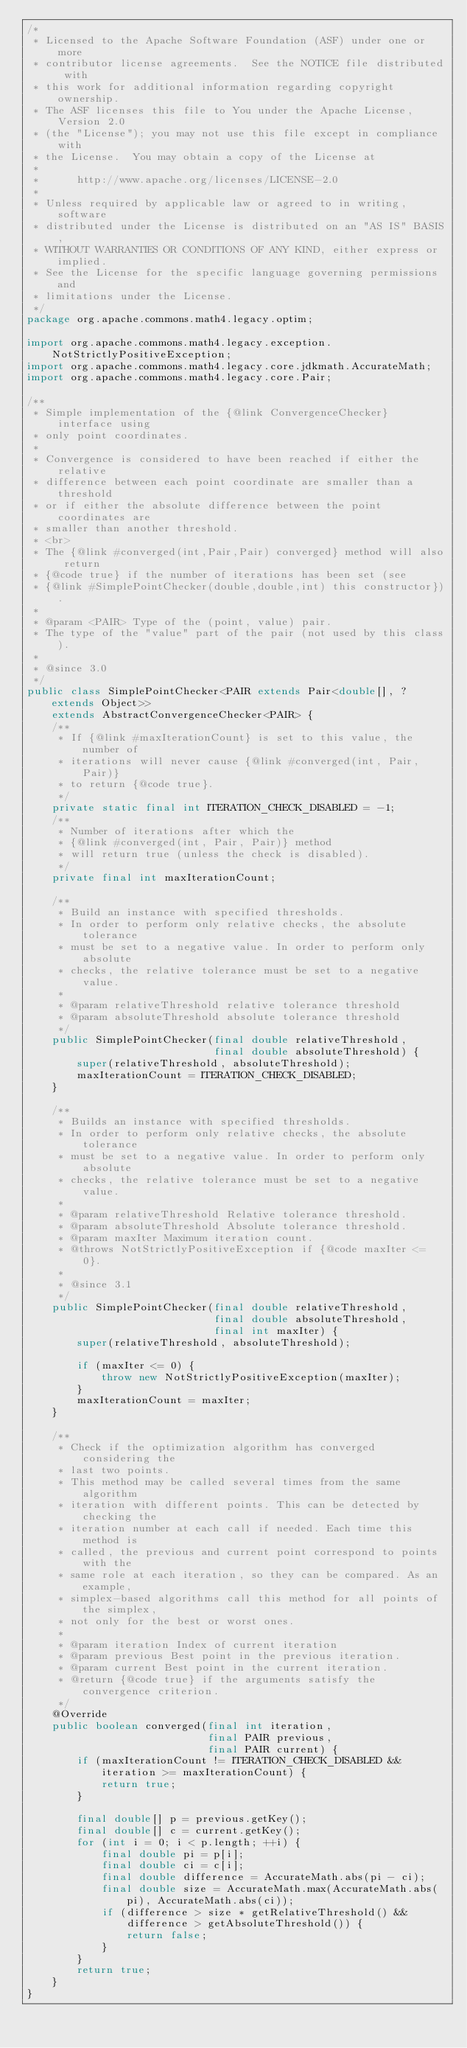Convert code to text. <code><loc_0><loc_0><loc_500><loc_500><_Java_>/*
 * Licensed to the Apache Software Foundation (ASF) under one or more
 * contributor license agreements.  See the NOTICE file distributed with
 * this work for additional information regarding copyright ownership.
 * The ASF licenses this file to You under the Apache License, Version 2.0
 * (the "License"); you may not use this file except in compliance with
 * the License.  You may obtain a copy of the License at
 *
 *      http://www.apache.org/licenses/LICENSE-2.0
 *
 * Unless required by applicable law or agreed to in writing, software
 * distributed under the License is distributed on an "AS IS" BASIS,
 * WITHOUT WARRANTIES OR CONDITIONS OF ANY KIND, either express or implied.
 * See the License for the specific language governing permissions and
 * limitations under the License.
 */
package org.apache.commons.math4.legacy.optim;

import org.apache.commons.math4.legacy.exception.NotStrictlyPositiveException;
import org.apache.commons.math4.legacy.core.jdkmath.AccurateMath;
import org.apache.commons.math4.legacy.core.Pair;

/**
 * Simple implementation of the {@link ConvergenceChecker} interface using
 * only point coordinates.
 *
 * Convergence is considered to have been reached if either the relative
 * difference between each point coordinate are smaller than a threshold
 * or if either the absolute difference between the point coordinates are
 * smaller than another threshold.
 * <br>
 * The {@link #converged(int,Pair,Pair) converged} method will also return
 * {@code true} if the number of iterations has been set (see
 * {@link #SimplePointChecker(double,double,int) this constructor}).
 *
 * @param <PAIR> Type of the (point, value) pair.
 * The type of the "value" part of the pair (not used by this class).
 *
 * @since 3.0
 */
public class SimplePointChecker<PAIR extends Pair<double[], ? extends Object>>
    extends AbstractConvergenceChecker<PAIR> {
    /**
     * If {@link #maxIterationCount} is set to this value, the number of
     * iterations will never cause {@link #converged(int, Pair, Pair)}
     * to return {@code true}.
     */
    private static final int ITERATION_CHECK_DISABLED = -1;
    /**
     * Number of iterations after which the
     * {@link #converged(int, Pair, Pair)} method
     * will return true (unless the check is disabled).
     */
    private final int maxIterationCount;

    /**
     * Build an instance with specified thresholds.
     * In order to perform only relative checks, the absolute tolerance
     * must be set to a negative value. In order to perform only absolute
     * checks, the relative tolerance must be set to a negative value.
     *
     * @param relativeThreshold relative tolerance threshold
     * @param absoluteThreshold absolute tolerance threshold
     */
    public SimplePointChecker(final double relativeThreshold,
                              final double absoluteThreshold) {
        super(relativeThreshold, absoluteThreshold);
        maxIterationCount = ITERATION_CHECK_DISABLED;
    }

    /**
     * Builds an instance with specified thresholds.
     * In order to perform only relative checks, the absolute tolerance
     * must be set to a negative value. In order to perform only absolute
     * checks, the relative tolerance must be set to a negative value.
     *
     * @param relativeThreshold Relative tolerance threshold.
     * @param absoluteThreshold Absolute tolerance threshold.
     * @param maxIter Maximum iteration count.
     * @throws NotStrictlyPositiveException if {@code maxIter <= 0}.
     *
     * @since 3.1
     */
    public SimplePointChecker(final double relativeThreshold,
                              final double absoluteThreshold,
                              final int maxIter) {
        super(relativeThreshold, absoluteThreshold);

        if (maxIter <= 0) {
            throw new NotStrictlyPositiveException(maxIter);
        }
        maxIterationCount = maxIter;
    }

    /**
     * Check if the optimization algorithm has converged considering the
     * last two points.
     * This method may be called several times from the same algorithm
     * iteration with different points. This can be detected by checking the
     * iteration number at each call if needed. Each time this method is
     * called, the previous and current point correspond to points with the
     * same role at each iteration, so they can be compared. As an example,
     * simplex-based algorithms call this method for all points of the simplex,
     * not only for the best or worst ones.
     *
     * @param iteration Index of current iteration
     * @param previous Best point in the previous iteration.
     * @param current Best point in the current iteration.
     * @return {@code true} if the arguments satisfy the convergence criterion.
     */
    @Override
    public boolean converged(final int iteration,
                             final PAIR previous,
                             final PAIR current) {
        if (maxIterationCount != ITERATION_CHECK_DISABLED && iteration >= maxIterationCount) {
            return true;
        }

        final double[] p = previous.getKey();
        final double[] c = current.getKey();
        for (int i = 0; i < p.length; ++i) {
            final double pi = p[i];
            final double ci = c[i];
            final double difference = AccurateMath.abs(pi - ci);
            final double size = AccurateMath.max(AccurateMath.abs(pi), AccurateMath.abs(ci));
            if (difference > size * getRelativeThreshold() &&
                difference > getAbsoluteThreshold()) {
                return false;
            }
        }
        return true;
    }
}
</code> 